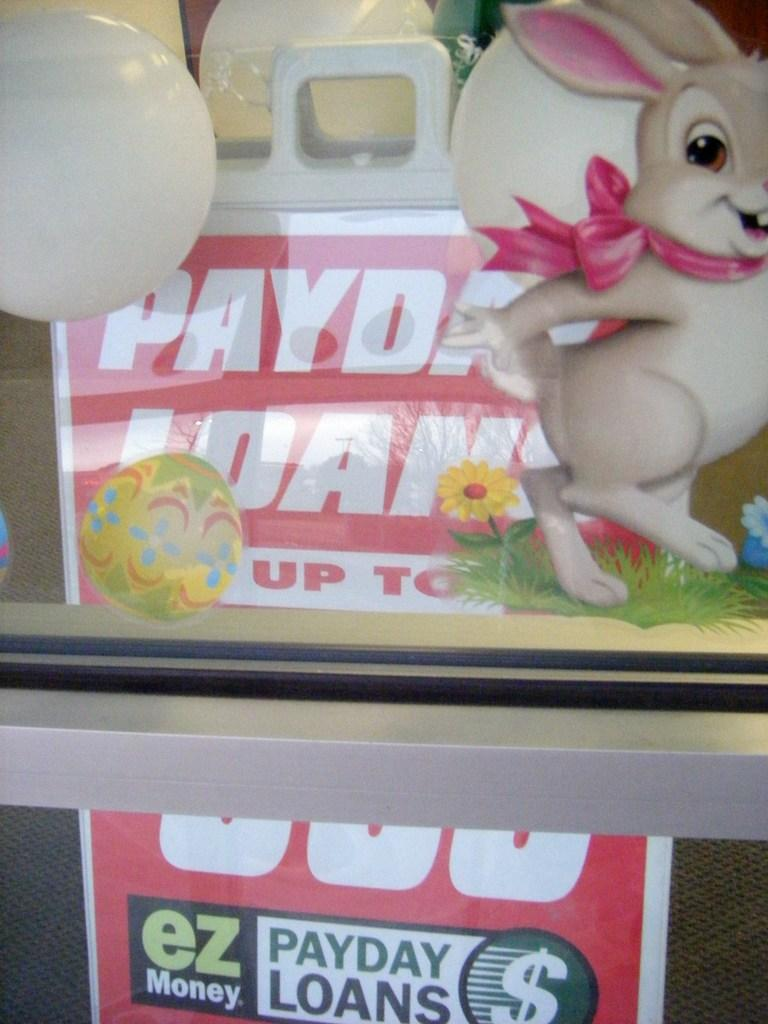Provide a one-sentence caption for the provided image. A sign sits inside of a window that reads payday loans. 